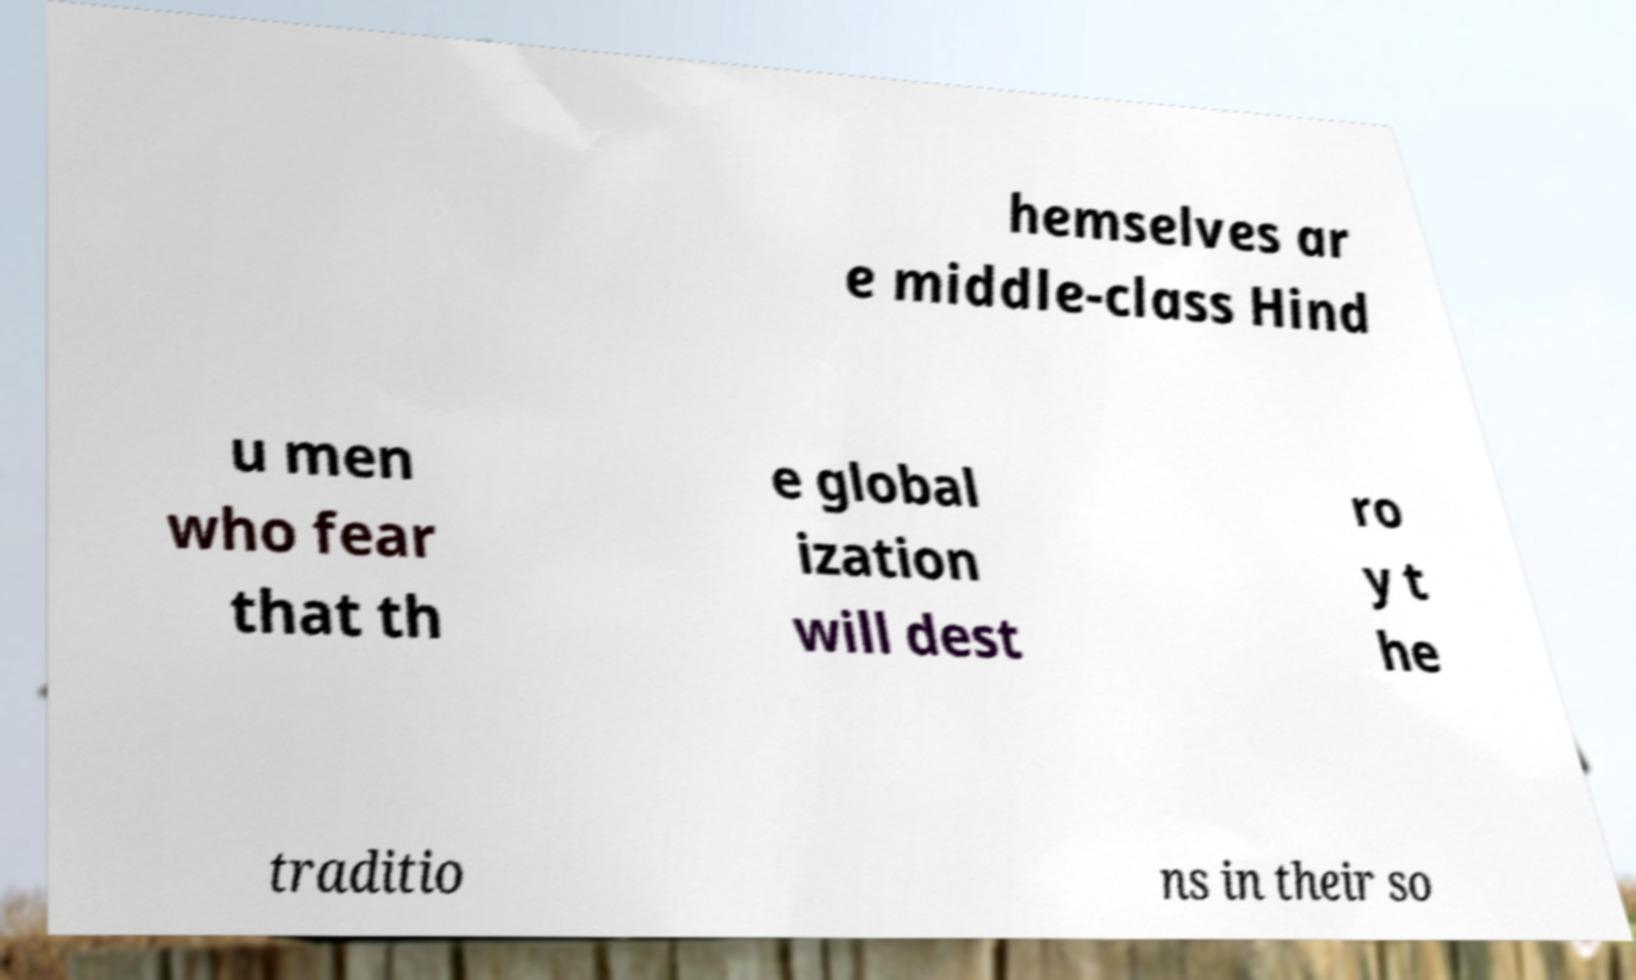What messages or text are displayed in this image? I need them in a readable, typed format. hemselves ar e middle-class Hind u men who fear that th e global ization will dest ro y t he traditio ns in their so 